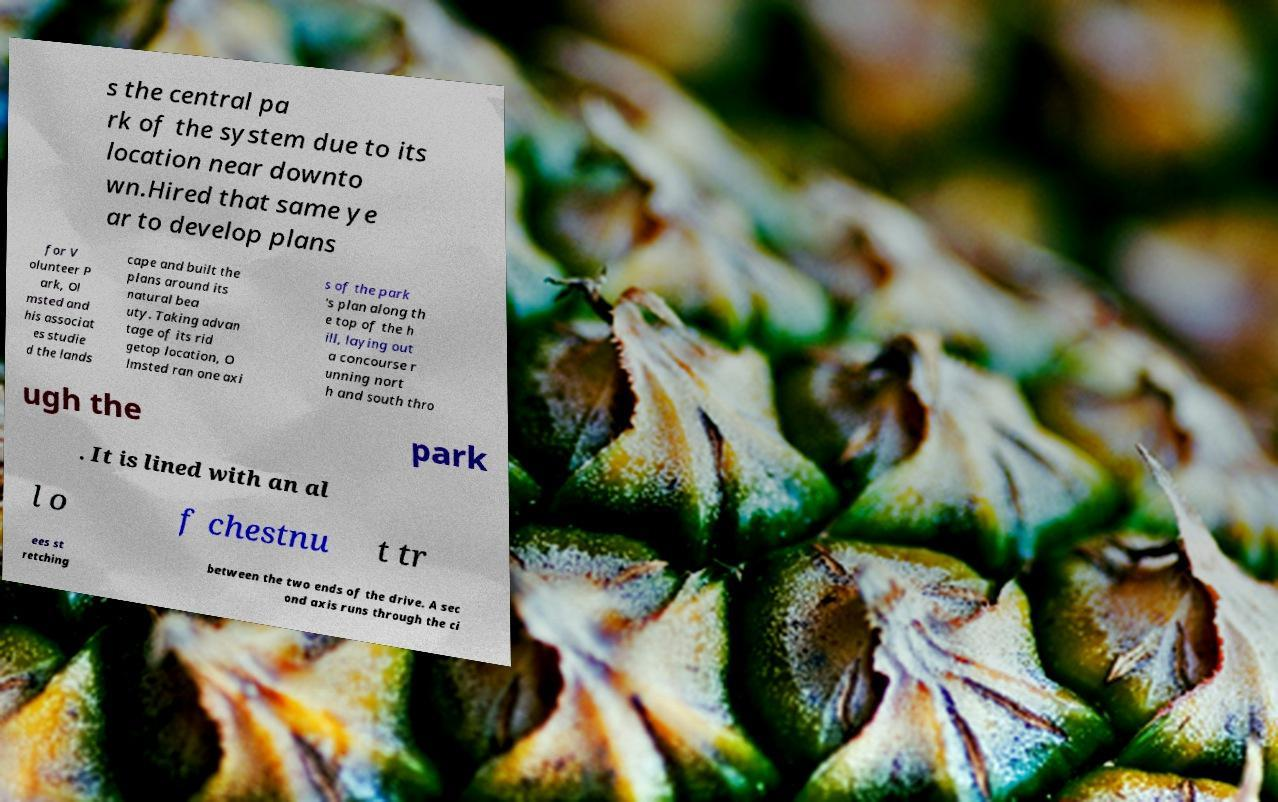I need the written content from this picture converted into text. Can you do that? s the central pa rk of the system due to its location near downto wn.Hired that same ye ar to develop plans for V olunteer P ark, Ol msted and his associat es studie d the lands cape and built the plans around its natural bea uty. Taking advan tage of its rid getop location, O lmsted ran one axi s of the park 's plan along th e top of the h ill, laying out a concourse r unning nort h and south thro ugh the park . It is lined with an al l o f chestnu t tr ees st retching between the two ends of the drive. A sec ond axis runs through the ci 